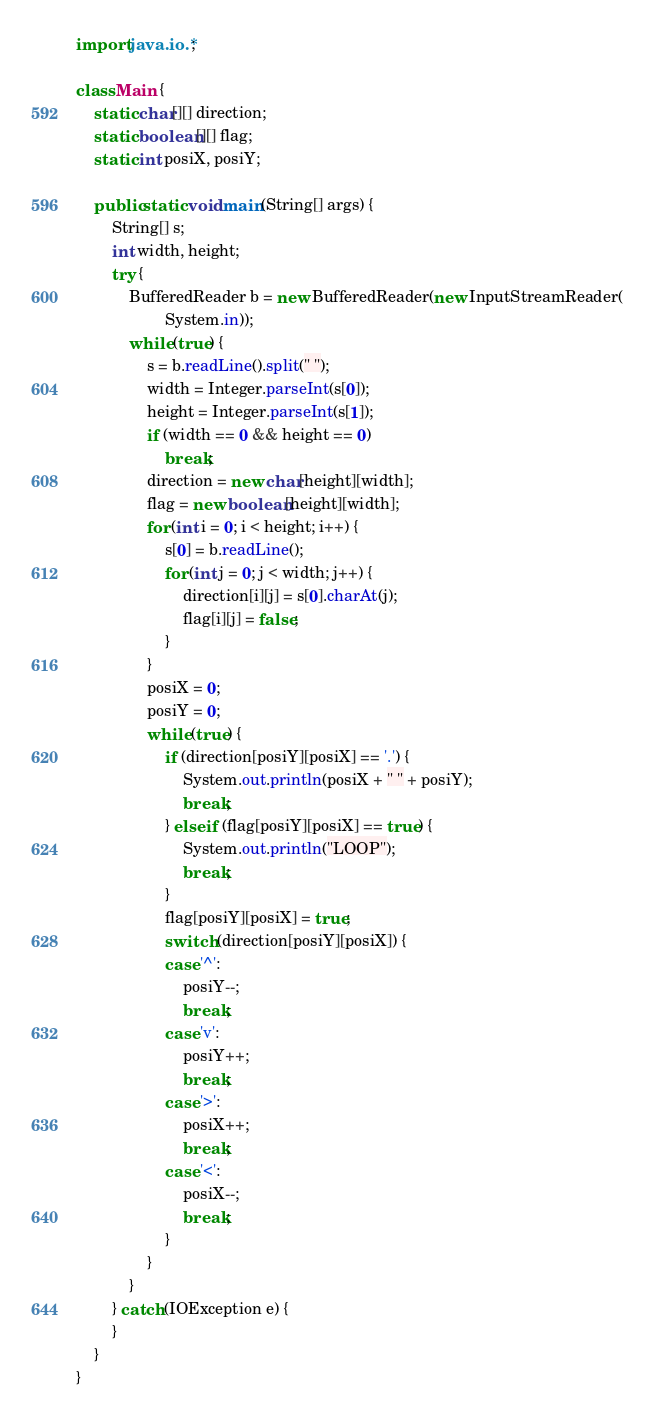Convert code to text. <code><loc_0><loc_0><loc_500><loc_500><_Java_>import java.io.*;

class Main {
	static char[][] direction;
	static boolean[][] flag;
	static int posiX, posiY;

	public static void main(String[] args) {
		String[] s;
		int width, height;
		try {
			BufferedReader b = new BufferedReader(new InputStreamReader(
					System.in));
			while (true) {
				s = b.readLine().split(" ");
				width = Integer.parseInt(s[0]);
				height = Integer.parseInt(s[1]);
				if (width == 0 && height == 0)
					break;
				direction = new char[height][width];
				flag = new boolean[height][width];
				for (int i = 0; i < height; i++) {
					s[0] = b.readLine();
					for (int j = 0; j < width; j++) {
						direction[i][j] = s[0].charAt(j);
						flag[i][j] = false;
					}
				}
				posiX = 0;
				posiY = 0;
				while (true) {
					if (direction[posiY][posiX] == '.') {
						System.out.println(posiX + " " + posiY);
						break;
					} else if (flag[posiY][posiX] == true) {
						System.out.println("LOOP");
						break;
					}
					flag[posiY][posiX] = true;
					switch (direction[posiY][posiX]) {
					case '^':
						posiY--;
						break;
					case 'v':
						posiY++;
						break;
					case '>':
						posiX++;
						break;
					case '<':
						posiX--;
						break;
					}
				}
			}
		} catch (IOException e) {
		}
	}
}</code> 